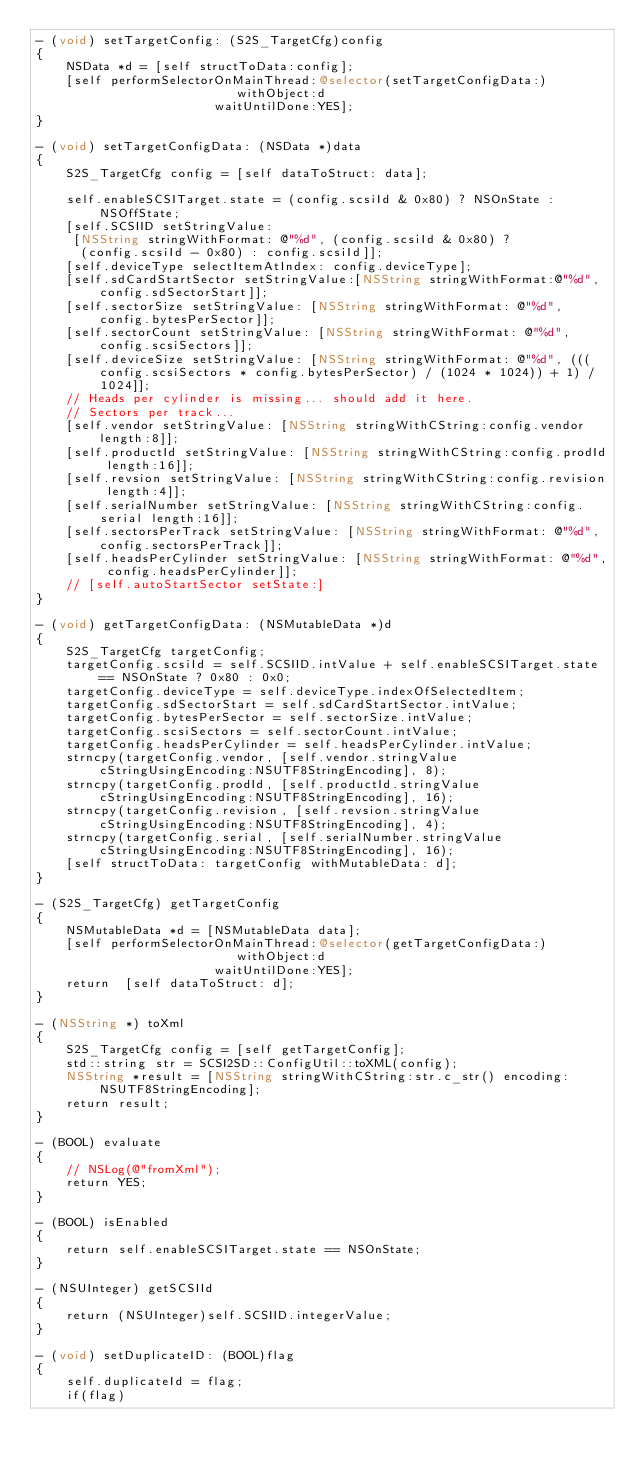Convert code to text. <code><loc_0><loc_0><loc_500><loc_500><_ObjectiveC_>- (void) setTargetConfig: (S2S_TargetCfg)config
{
    NSData *d = [self structToData:config];
    [self performSelectorOnMainThread:@selector(setTargetConfigData:)
                           withObject:d
                        waitUntilDone:YES];
}

- (void) setTargetConfigData: (NSData *)data
{
    S2S_TargetCfg config = [self dataToStruct: data];
    
    self.enableSCSITarget.state = (config.scsiId & 0x80) ? NSOnState : NSOffState;
    [self.SCSIID setStringValue:
     [NSString stringWithFormat: @"%d", (config.scsiId & 0x80) ?
      (config.scsiId - 0x80) : config.scsiId]];
    [self.deviceType selectItemAtIndex: config.deviceType];
    [self.sdCardStartSector setStringValue:[NSString stringWithFormat:@"%d", config.sdSectorStart]];
    [self.sectorSize setStringValue: [NSString stringWithFormat: @"%d", config.bytesPerSector]];
    [self.sectorCount setStringValue: [NSString stringWithFormat: @"%d", config.scsiSectors]];
    [self.deviceSize setStringValue: [NSString stringWithFormat: @"%d", (((config.scsiSectors * config.bytesPerSector) / (1024 * 1024)) + 1) / 1024]];
    // Heads per cylinder is missing... should add it here.
    // Sectors per track...
    [self.vendor setStringValue: [NSString stringWithCString:config.vendor length:8]];
    [self.productId setStringValue: [NSString stringWithCString:config.prodId length:16]];
    [self.revsion setStringValue: [NSString stringWithCString:config.revision length:4]];
    [self.serialNumber setStringValue: [NSString stringWithCString:config.serial length:16]];
    [self.sectorsPerTrack setStringValue: [NSString stringWithFormat: @"%d", config.sectorsPerTrack]];
    [self.headsPerCylinder setStringValue: [NSString stringWithFormat: @"%d", config.headsPerCylinder]];
    // [self.autoStartSector setState:]
}

- (void) getTargetConfigData: (NSMutableData *)d
{
    S2S_TargetCfg targetConfig;
    targetConfig.scsiId = self.SCSIID.intValue + self.enableSCSITarget.state == NSOnState ? 0x80 : 0x0;
    targetConfig.deviceType = self.deviceType.indexOfSelectedItem;
    targetConfig.sdSectorStart = self.sdCardStartSector.intValue;
    targetConfig.bytesPerSector = self.sectorSize.intValue;
    targetConfig.scsiSectors = self.sectorCount.intValue;
    targetConfig.headsPerCylinder = self.headsPerCylinder.intValue;
    strncpy(targetConfig.vendor, [self.vendor.stringValue cStringUsingEncoding:NSUTF8StringEncoding], 8);
    strncpy(targetConfig.prodId, [self.productId.stringValue cStringUsingEncoding:NSUTF8StringEncoding], 16);
    strncpy(targetConfig.revision, [self.revsion.stringValue cStringUsingEncoding:NSUTF8StringEncoding], 4);
    strncpy(targetConfig.serial, [self.serialNumber.stringValue cStringUsingEncoding:NSUTF8StringEncoding], 16);
    [self structToData: targetConfig withMutableData: d];
}

- (S2S_TargetCfg) getTargetConfig
{
    NSMutableData *d = [NSMutableData data];
    [self performSelectorOnMainThread:@selector(getTargetConfigData:)
                           withObject:d
                        waitUntilDone:YES];
    return  [self dataToStruct: d];
}

- (NSString *) toXml
{
    S2S_TargetCfg config = [self getTargetConfig];
    std::string str = SCSI2SD::ConfigUtil::toXML(config);
    NSString *result = [NSString stringWithCString:str.c_str() encoding:NSUTF8StringEncoding];
    return result;
}

- (BOOL) evaluate
{
    // NSLog(@"fromXml");
    return YES;
}

- (BOOL) isEnabled
{
    return self.enableSCSITarget.state == NSOnState;
}

- (NSUInteger) getSCSIId
{
    return (NSUInteger)self.SCSIID.integerValue;
}

- (void) setDuplicateID: (BOOL)flag
{
    self.duplicateId = flag;
    if(flag)</code> 